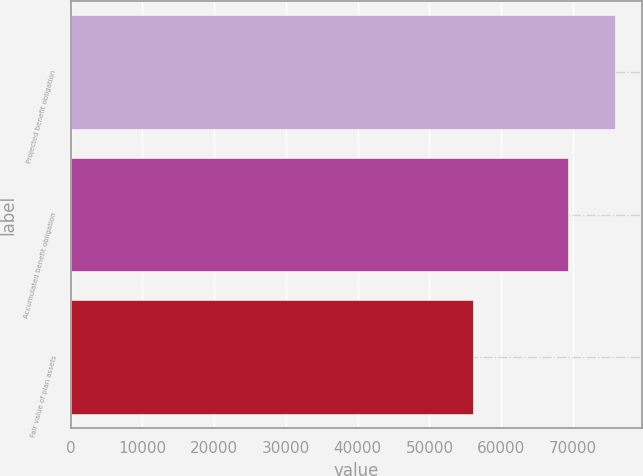Convert chart to OTSL. <chart><loc_0><loc_0><loc_500><loc_500><bar_chart><fcel>Projected benefit obligation<fcel>Accumulated benefit obligation<fcel>Fair value of plan assets<nl><fcel>75851<fcel>69272<fcel>56129<nl></chart> 